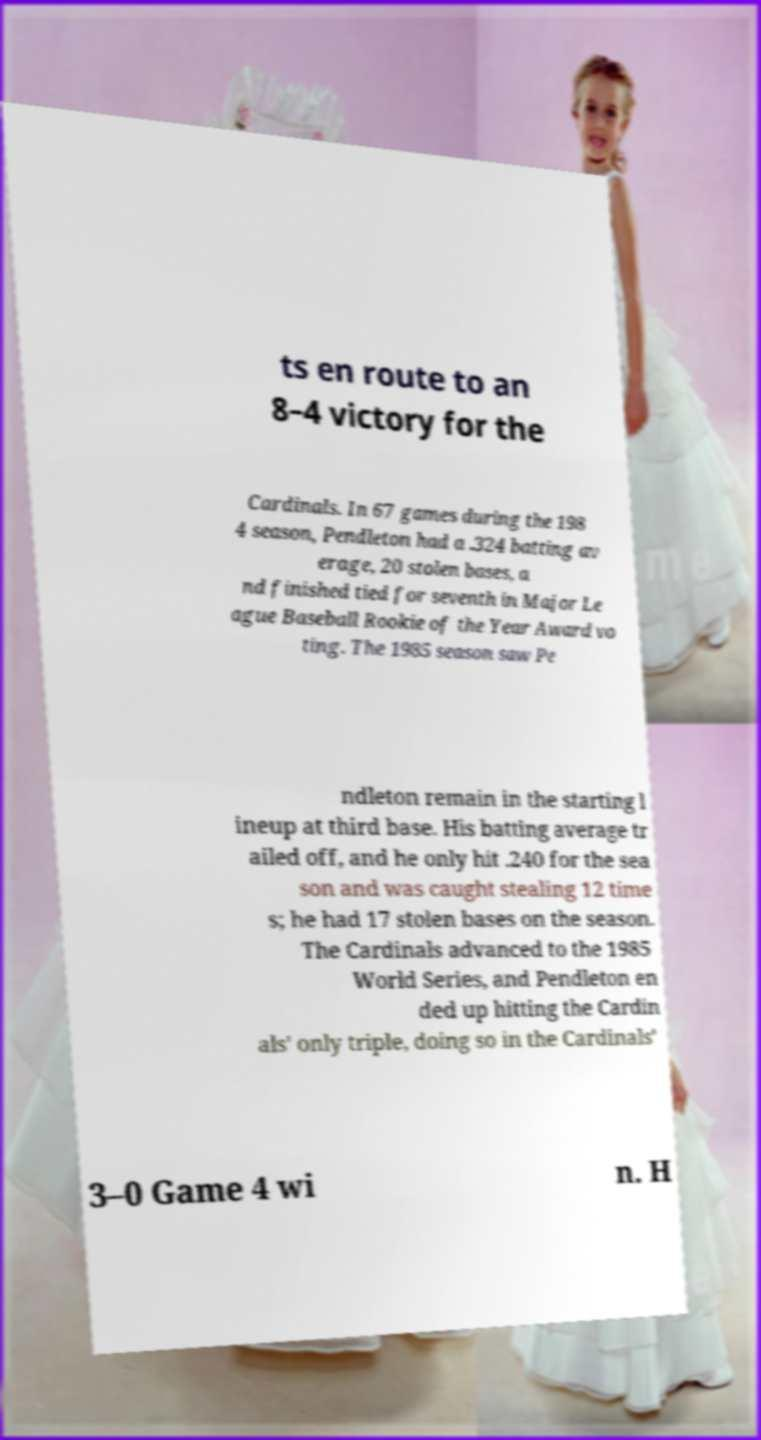Can you read and provide the text displayed in the image?This photo seems to have some interesting text. Can you extract and type it out for me? ts en route to an 8–4 victory for the Cardinals. In 67 games during the 198 4 season, Pendleton had a .324 batting av erage, 20 stolen bases, a nd finished tied for seventh in Major Le ague Baseball Rookie of the Year Award vo ting. The 1985 season saw Pe ndleton remain in the starting l ineup at third base. His batting average tr ailed off, and he only hit .240 for the sea son and was caught stealing 12 time s; he had 17 stolen bases on the season. The Cardinals advanced to the 1985 World Series, and Pendleton en ded up hitting the Cardin als' only triple, doing so in the Cardinals' 3–0 Game 4 wi n. H 